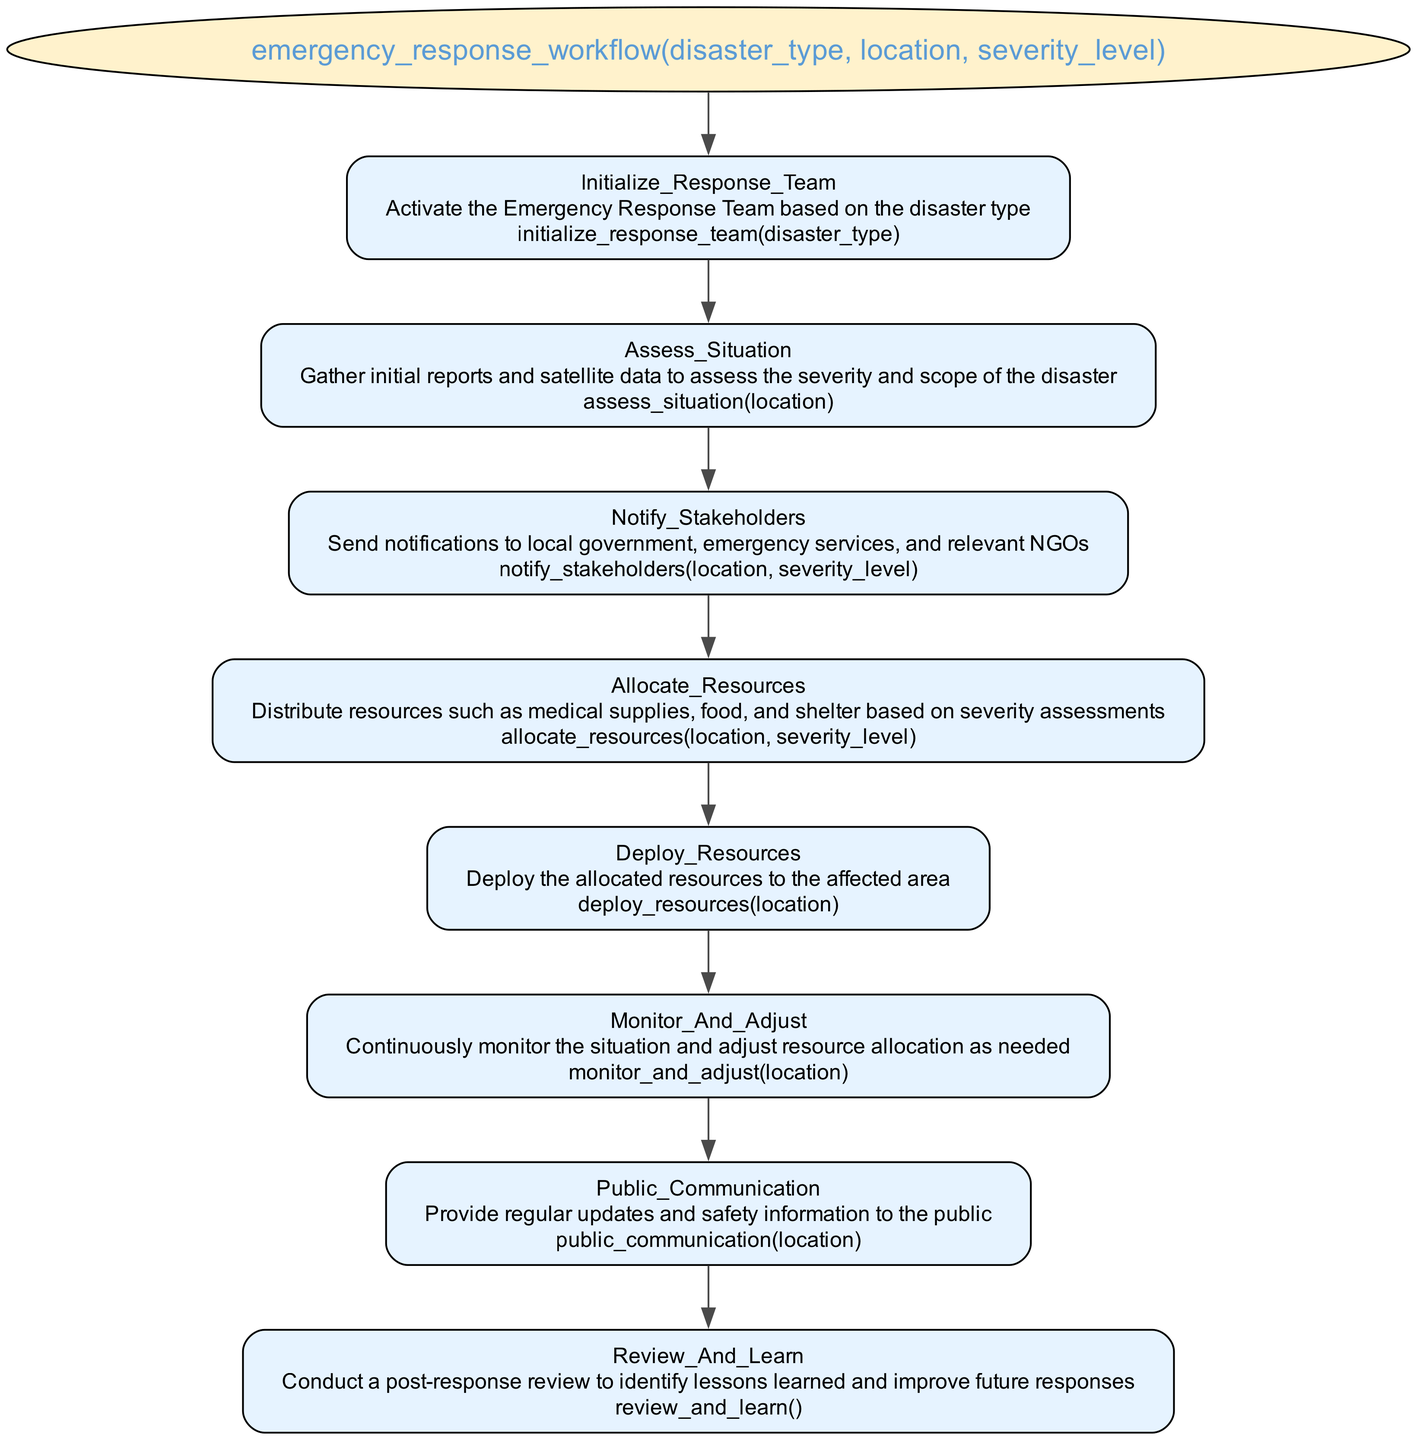what is the function name in the diagram? The function name is prominently displayed at the top of the diagram in an ellipse shape. By looking at the label of that node, we see it reads “emergency_response_workflow”.
Answer: emergency_response_workflow how many parameters does the function have? The function parameters are listed just below the function name in parentheses. There are three parameters: "disaster_type", "location", and "severity_level". Counting these, we find there are three parameters.
Answer: three what is the first step in the emergency response workflow? The first step in the workflow is listed as "Initialize_Response_Team". It is the first node connected under the function name, indicating it is the initial action taken in the process.
Answer: Initialize_Response_Team which step directly follows "Assess_Situation"? By examining the order of the steps in the flowchart, "Notify_Stakeholders" is the node that follows "Assess_Situation", indicating it is the next action taken after assessing the situation.
Answer: Notify_Stakeholders what function is called to allocate resources? Within the description of the "Allocate_Resources" step, the function called is specified as “allocate_resources(location, severity_level)”. This clear reference indicates what function is used for this task.
Answer: allocate_resources(location, severity_level) how many steps are there in total in the emergency response workflow? The steps are listed consecutively in the diagram below the function name, and by counting them one by one, we identify eight steps in total from "Initialize_Response_Team" to "Review_And_Learn".
Answer: eight which element involves public communication? The element involved in public communication is labeled as "Public_Communication", which directly indicates that this step is focused on providing information to the public.
Answer: Public_Communication what happens after resources are deployed? After the deployment of resources, the next step is "Monitor_And_Adjust". This indicates continuous monitoring of the situation is required after the resources are sent to the affected area.
Answer: Monitor_And_Adjust what is the last step in the emergency response workflow? The last step in the workflow, as shown at the bottom of the flowchart, is "Review_And_Learn". This step signifies the conclusion of the workflow with the aim of learning from the experience.
Answer: Review_And_Learn 